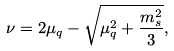<formula> <loc_0><loc_0><loc_500><loc_500>\nu = 2 \mu _ { q } - \sqrt { \mu _ { q } ^ { 2 } + \frac { m _ { s } ^ { 2 } } { 3 } } ,</formula> 